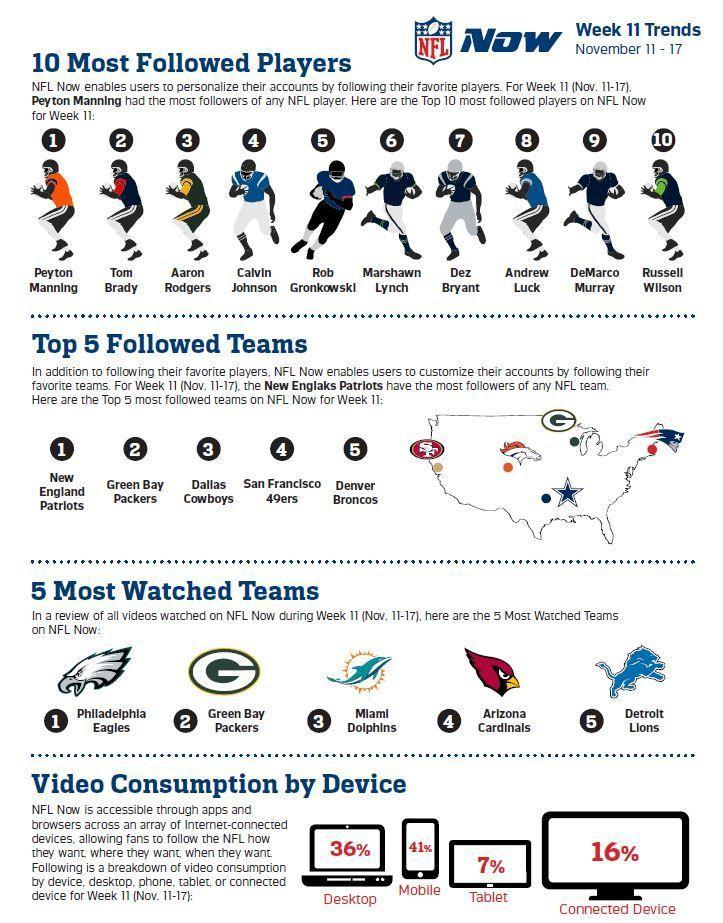Which player is placed two places left of the sixth ranking player?
Answer the question with a short phrase. Calvin Johnson Which device is used the most to access NFL, Desktop, Mobile, or Tablet ? Mobile What percentage of viewers use connected devices to follow NFL, 36%, 41%, 7%, or 16%? 16% Where is the headquarters of the San Fransisco 49ers, Santa Clara, Colorado, or Boston? Santa Clara Which player is placed three places right of the player ranked seven? Russel Wilson 